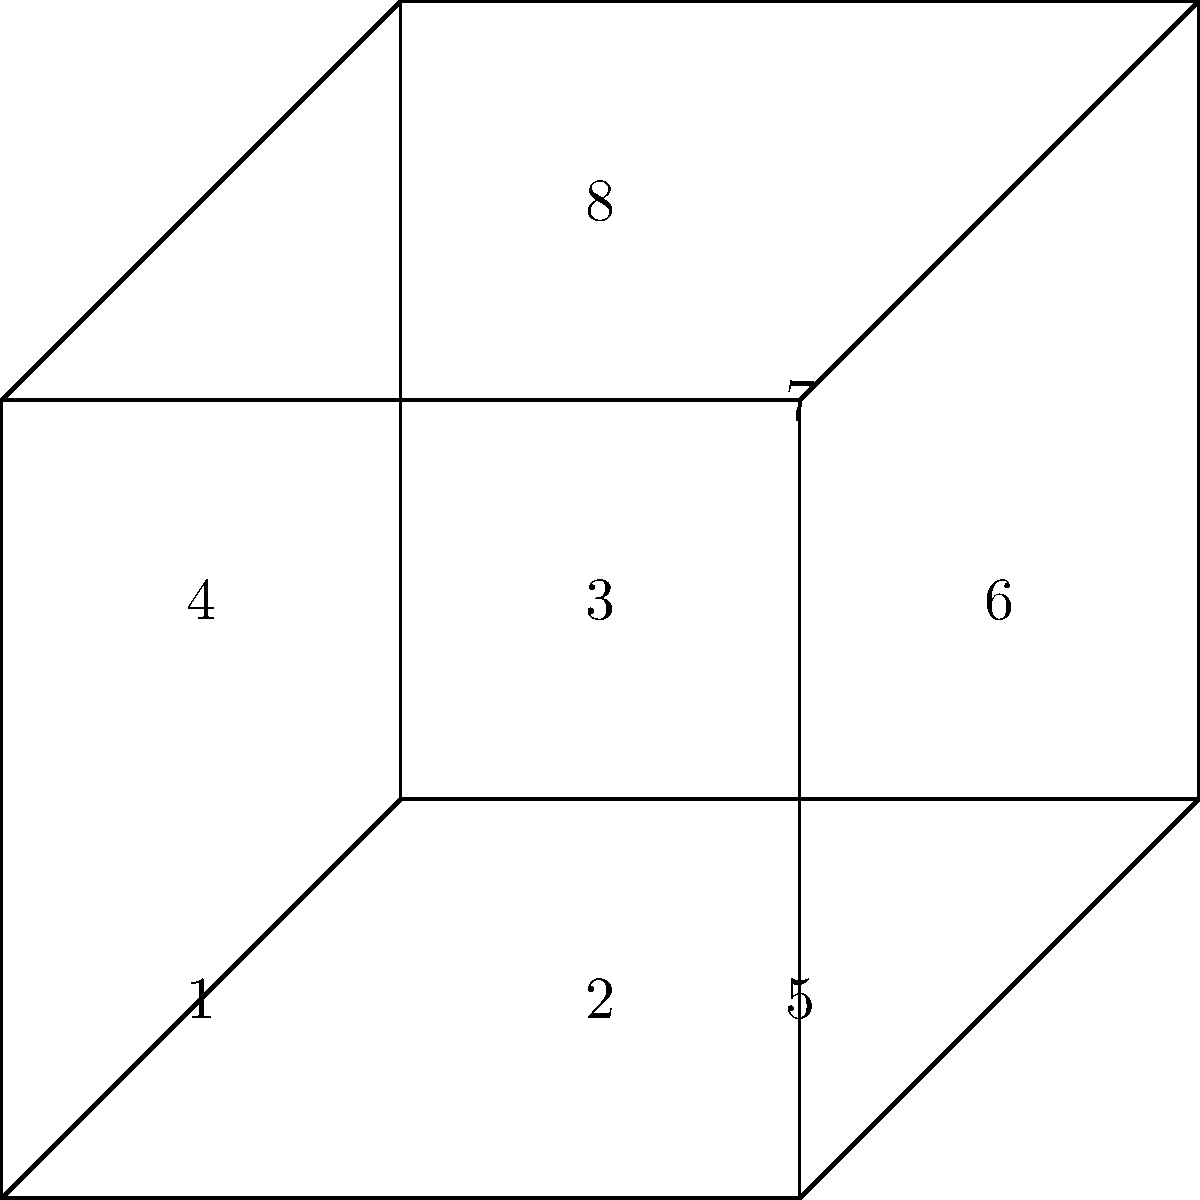In the wrestling tournament bracket structure shown above, which regions represent congruent shapes? Consider the numbered areas and identify all pairs of congruent regions. To determine congruent shapes in this wrestling tournament bracket, we need to analyze the geometric properties of each region:

1. First, observe that the overall structure is composed of two squares: an outer square (ABCD) and an inner square (EFGH).

2. The lines connecting the vertices of these squares divide the space into 8 distinct regions, numbered 1 through 8.

3. Let's analyze each pair of regions:
   - Regions 1, 2, 3, and 4 are all congruent trapezoids within the outer square ABCD.
   - Regions 5, 6, 7, and 8 are all congruent right triangles formed by the space between the outer and inner squares.

4. To prove congruence:
   - For trapezoids 1, 2, 3, and 4:
     * They share the same height (half the side length of square ABCD)
     * Their parallel sides are equal (one side is half of ABCD, the other is half of EFGH)
   - For triangles 5, 6, 7, and 8:
     * They are all right triangles
     * They share the same base and height (the difference between the sides of ABCD and EFGH)

5. Therefore, the congruent pairs are:
   - (1,2), (1,3), (1,4), (2,3), (2,4), (3,4)
   - (5,6), (5,7), (5,8), (6,7), (6,8), (7,8)

All trapezoids are congruent to each other, and all triangles are congruent to each other.
Answer: (1,2,3,4), (5,6,7,8) 